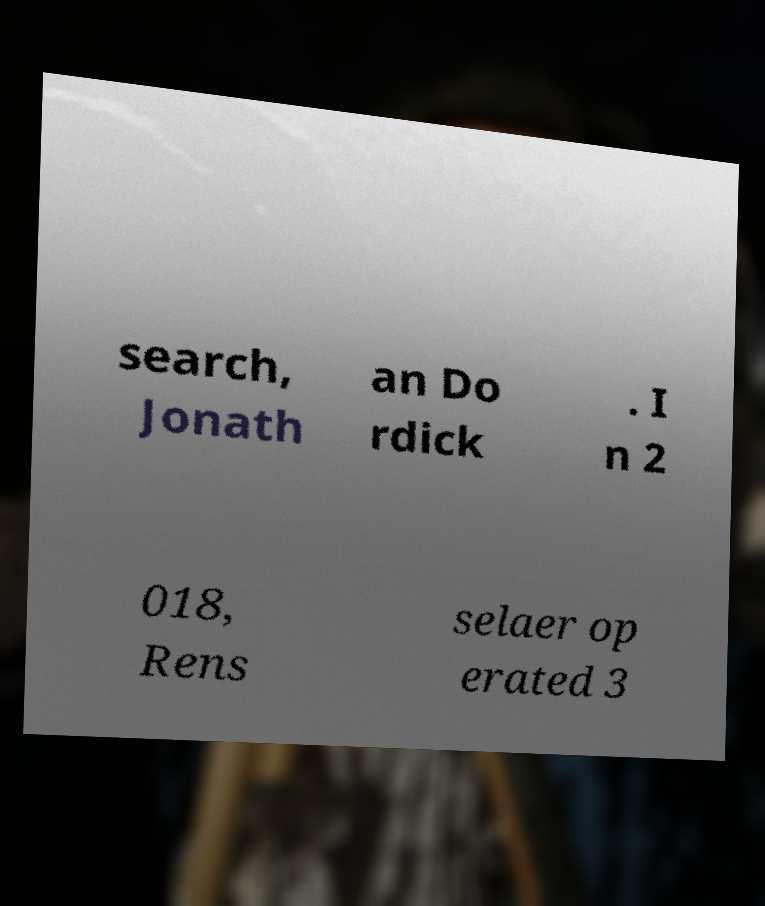Please read and relay the text visible in this image. What does it say? search, Jonath an Do rdick . I n 2 018, Rens selaer op erated 3 